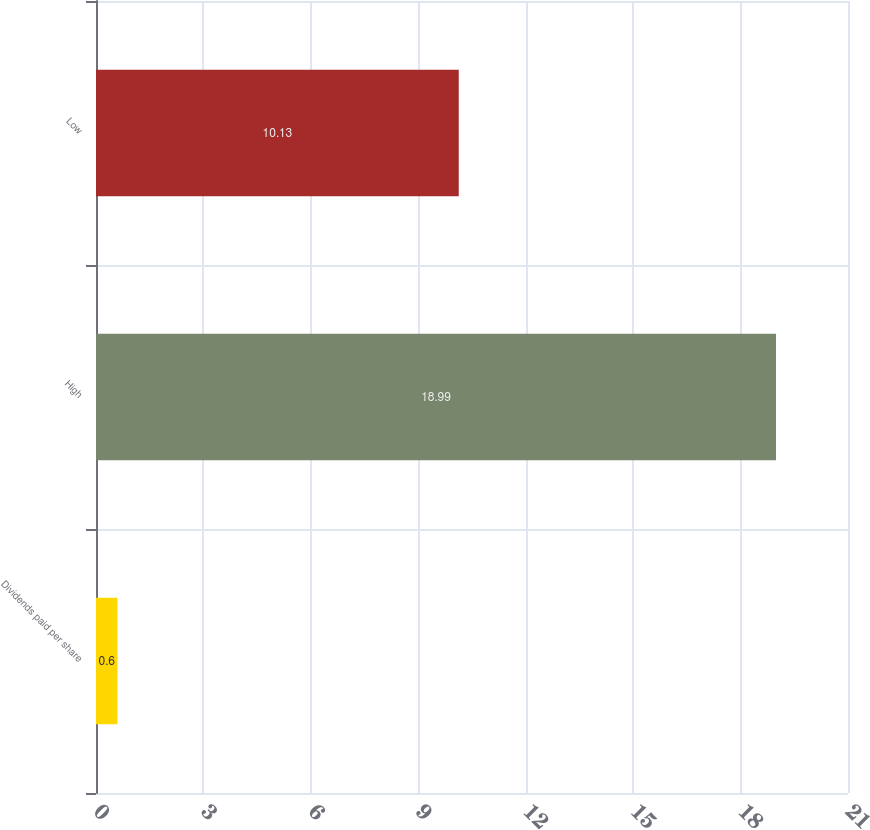Convert chart to OTSL. <chart><loc_0><loc_0><loc_500><loc_500><bar_chart><fcel>Dividends paid per share<fcel>High<fcel>Low<nl><fcel>0.6<fcel>18.99<fcel>10.13<nl></chart> 